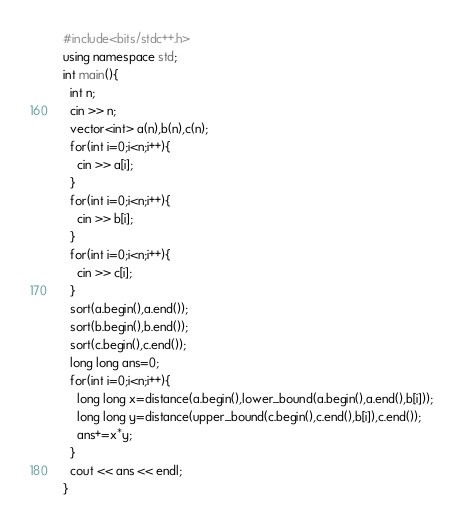Convert code to text. <code><loc_0><loc_0><loc_500><loc_500><_C++_>#include<bits/stdc++.h>
using namespace std;
int main(){
  int n;
  cin >> n;
  vector<int> a(n),b(n),c(n);
  for(int i=0;i<n;i++){
    cin >> a[i];
  }
  for(int i=0;i<n;i++){
    cin >> b[i];
  }
  for(int i=0;i<n;i++){
    cin >> c[i];
  }
  sort(a.begin(),a.end());
  sort(b.begin(),b.end());
  sort(c.begin(),c.end());
  long long ans=0;
  for(int i=0;i<n;i++){
    long long x=distance(a.begin(),lower_bound(a.begin(),a.end(),b[i]));
    long long y=distance(upper_bound(c.begin(),c.end(),b[i]),c.end());
    ans+=x*y;
  }
  cout << ans << endl;
}</code> 